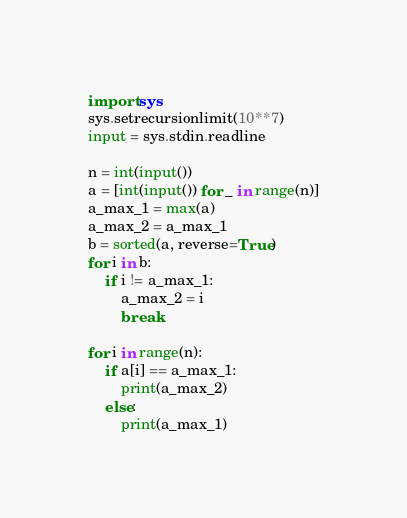<code> <loc_0><loc_0><loc_500><loc_500><_Python_>import sys
sys.setrecursionlimit(10**7)
input = sys.stdin.readline

n = int(input())
a = [int(input()) for _ in range(n)]
a_max_1 = max(a)
a_max_2 = a_max_1
b = sorted(a, reverse=True)
for i in b:
    if i != a_max_1:
        a_max_2 = i
        break

for i in range(n):
    if a[i] == a_max_1:
        print(a_max_2)
    else:
        print(a_max_1)
</code> 